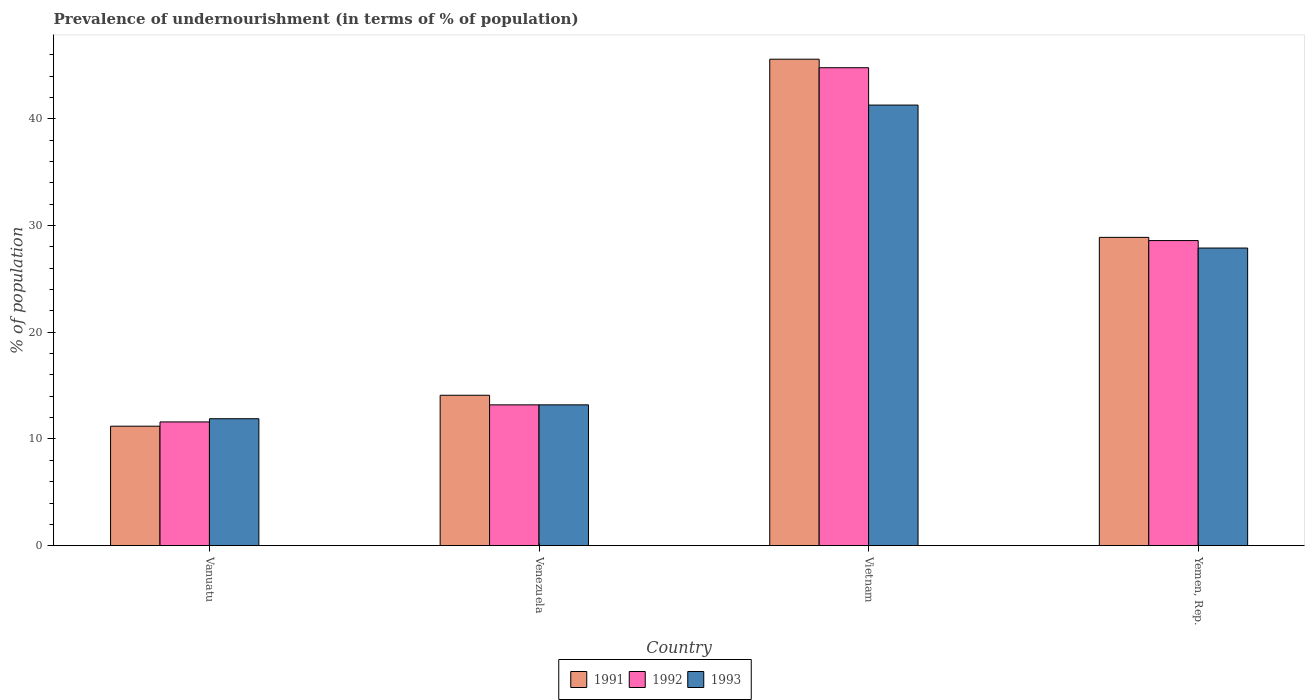How many groups of bars are there?
Offer a terse response. 4. How many bars are there on the 2nd tick from the right?
Your answer should be compact. 3. What is the label of the 2nd group of bars from the left?
Provide a short and direct response. Venezuela. In how many cases, is the number of bars for a given country not equal to the number of legend labels?
Keep it short and to the point. 0. What is the percentage of undernourished population in 1991 in Vietnam?
Your answer should be very brief. 45.6. Across all countries, what is the maximum percentage of undernourished population in 1991?
Your answer should be compact. 45.6. In which country was the percentage of undernourished population in 1992 maximum?
Offer a very short reply. Vietnam. In which country was the percentage of undernourished population in 1993 minimum?
Your answer should be very brief. Vanuatu. What is the total percentage of undernourished population in 1992 in the graph?
Make the answer very short. 98.2. What is the difference between the percentage of undernourished population in 1992 in Venezuela and that in Yemen, Rep.?
Provide a short and direct response. -15.4. What is the average percentage of undernourished population in 1993 per country?
Give a very brief answer. 23.58. What is the difference between the percentage of undernourished population of/in 1992 and percentage of undernourished population of/in 1991 in Venezuela?
Your answer should be compact. -0.9. In how many countries, is the percentage of undernourished population in 1993 greater than 14 %?
Your response must be concise. 2. What is the ratio of the percentage of undernourished population in 1991 in Vanuatu to that in Yemen, Rep.?
Your response must be concise. 0.39. Is the percentage of undernourished population in 1993 in Venezuela less than that in Yemen, Rep.?
Provide a succinct answer. Yes. What is the difference between the highest and the second highest percentage of undernourished population in 1992?
Your response must be concise. -31.6. What is the difference between the highest and the lowest percentage of undernourished population in 1992?
Provide a succinct answer. 33.2. Is the sum of the percentage of undernourished population in 1993 in Vanuatu and Yemen, Rep. greater than the maximum percentage of undernourished population in 1991 across all countries?
Your response must be concise. No. Is it the case that in every country, the sum of the percentage of undernourished population in 1991 and percentage of undernourished population in 1992 is greater than the percentage of undernourished population in 1993?
Your response must be concise. Yes. How many bars are there?
Keep it short and to the point. 12. Are all the bars in the graph horizontal?
Offer a very short reply. No. How many countries are there in the graph?
Provide a succinct answer. 4. Where does the legend appear in the graph?
Provide a short and direct response. Bottom center. What is the title of the graph?
Offer a very short reply. Prevalence of undernourishment (in terms of % of population). What is the label or title of the X-axis?
Offer a very short reply. Country. What is the label or title of the Y-axis?
Provide a short and direct response. % of population. What is the % of population of 1991 in Vanuatu?
Ensure brevity in your answer.  11.2. What is the % of population in 1992 in Vanuatu?
Your answer should be very brief. 11.6. What is the % of population of 1993 in Vanuatu?
Make the answer very short. 11.9. What is the % of population in 1991 in Venezuela?
Offer a very short reply. 14.1. What is the % of population in 1993 in Venezuela?
Provide a succinct answer. 13.2. What is the % of population in 1991 in Vietnam?
Your response must be concise. 45.6. What is the % of population of 1992 in Vietnam?
Your answer should be very brief. 44.8. What is the % of population of 1993 in Vietnam?
Give a very brief answer. 41.3. What is the % of population in 1991 in Yemen, Rep.?
Provide a short and direct response. 28.9. What is the % of population of 1992 in Yemen, Rep.?
Provide a succinct answer. 28.6. What is the % of population of 1993 in Yemen, Rep.?
Your answer should be very brief. 27.9. Across all countries, what is the maximum % of population in 1991?
Ensure brevity in your answer.  45.6. Across all countries, what is the maximum % of population of 1992?
Provide a succinct answer. 44.8. Across all countries, what is the maximum % of population of 1993?
Your response must be concise. 41.3. Across all countries, what is the minimum % of population of 1992?
Offer a very short reply. 11.6. Across all countries, what is the minimum % of population in 1993?
Your answer should be very brief. 11.9. What is the total % of population in 1991 in the graph?
Keep it short and to the point. 99.8. What is the total % of population in 1992 in the graph?
Your answer should be very brief. 98.2. What is the total % of population in 1993 in the graph?
Provide a short and direct response. 94.3. What is the difference between the % of population in 1991 in Vanuatu and that in Venezuela?
Your answer should be compact. -2.9. What is the difference between the % of population in 1991 in Vanuatu and that in Vietnam?
Provide a succinct answer. -34.4. What is the difference between the % of population of 1992 in Vanuatu and that in Vietnam?
Offer a terse response. -33.2. What is the difference between the % of population of 1993 in Vanuatu and that in Vietnam?
Provide a succinct answer. -29.4. What is the difference between the % of population of 1991 in Vanuatu and that in Yemen, Rep.?
Your answer should be compact. -17.7. What is the difference between the % of population of 1992 in Vanuatu and that in Yemen, Rep.?
Give a very brief answer. -17. What is the difference between the % of population in 1991 in Venezuela and that in Vietnam?
Make the answer very short. -31.5. What is the difference between the % of population in 1992 in Venezuela and that in Vietnam?
Offer a terse response. -31.6. What is the difference between the % of population of 1993 in Venezuela and that in Vietnam?
Keep it short and to the point. -28.1. What is the difference between the % of population in 1991 in Venezuela and that in Yemen, Rep.?
Your answer should be very brief. -14.8. What is the difference between the % of population of 1992 in Venezuela and that in Yemen, Rep.?
Your response must be concise. -15.4. What is the difference between the % of population in 1993 in Venezuela and that in Yemen, Rep.?
Your answer should be compact. -14.7. What is the difference between the % of population of 1992 in Vietnam and that in Yemen, Rep.?
Your answer should be compact. 16.2. What is the difference between the % of population in 1991 in Vanuatu and the % of population in 1992 in Venezuela?
Offer a very short reply. -2. What is the difference between the % of population in 1992 in Vanuatu and the % of population in 1993 in Venezuela?
Your response must be concise. -1.6. What is the difference between the % of population of 1991 in Vanuatu and the % of population of 1992 in Vietnam?
Offer a terse response. -33.6. What is the difference between the % of population in 1991 in Vanuatu and the % of population in 1993 in Vietnam?
Your answer should be compact. -30.1. What is the difference between the % of population in 1992 in Vanuatu and the % of population in 1993 in Vietnam?
Provide a succinct answer. -29.7. What is the difference between the % of population in 1991 in Vanuatu and the % of population in 1992 in Yemen, Rep.?
Make the answer very short. -17.4. What is the difference between the % of population of 1991 in Vanuatu and the % of population of 1993 in Yemen, Rep.?
Offer a terse response. -16.7. What is the difference between the % of population in 1992 in Vanuatu and the % of population in 1993 in Yemen, Rep.?
Keep it short and to the point. -16.3. What is the difference between the % of population of 1991 in Venezuela and the % of population of 1992 in Vietnam?
Make the answer very short. -30.7. What is the difference between the % of population of 1991 in Venezuela and the % of population of 1993 in Vietnam?
Make the answer very short. -27.2. What is the difference between the % of population of 1992 in Venezuela and the % of population of 1993 in Vietnam?
Keep it short and to the point. -28.1. What is the difference between the % of population in 1991 in Venezuela and the % of population in 1992 in Yemen, Rep.?
Keep it short and to the point. -14.5. What is the difference between the % of population in 1991 in Venezuela and the % of population in 1993 in Yemen, Rep.?
Your answer should be compact. -13.8. What is the difference between the % of population in 1992 in Venezuela and the % of population in 1993 in Yemen, Rep.?
Your answer should be very brief. -14.7. What is the difference between the % of population of 1991 in Vietnam and the % of population of 1992 in Yemen, Rep.?
Offer a terse response. 17. What is the difference between the % of population of 1991 in Vietnam and the % of population of 1993 in Yemen, Rep.?
Give a very brief answer. 17.7. What is the difference between the % of population of 1992 in Vietnam and the % of population of 1993 in Yemen, Rep.?
Your answer should be compact. 16.9. What is the average % of population in 1991 per country?
Ensure brevity in your answer.  24.95. What is the average % of population in 1992 per country?
Your answer should be compact. 24.55. What is the average % of population in 1993 per country?
Offer a terse response. 23.57. What is the difference between the % of population in 1991 and % of population in 1993 in Vanuatu?
Your answer should be very brief. -0.7. What is the difference between the % of population of 1992 and % of population of 1993 in Vanuatu?
Ensure brevity in your answer.  -0.3. What is the difference between the % of population of 1991 and % of population of 1992 in Venezuela?
Your answer should be very brief. 0.9. What is the difference between the % of population in 1991 and % of population in 1992 in Vietnam?
Make the answer very short. 0.8. What is the difference between the % of population of 1991 and % of population of 1992 in Yemen, Rep.?
Your response must be concise. 0.3. What is the difference between the % of population in 1991 and % of population in 1993 in Yemen, Rep.?
Make the answer very short. 1. What is the difference between the % of population in 1992 and % of population in 1993 in Yemen, Rep.?
Provide a succinct answer. 0.7. What is the ratio of the % of population in 1991 in Vanuatu to that in Venezuela?
Provide a succinct answer. 0.79. What is the ratio of the % of population of 1992 in Vanuatu to that in Venezuela?
Your answer should be very brief. 0.88. What is the ratio of the % of population in 1993 in Vanuatu to that in Venezuela?
Offer a terse response. 0.9. What is the ratio of the % of population of 1991 in Vanuatu to that in Vietnam?
Your response must be concise. 0.25. What is the ratio of the % of population in 1992 in Vanuatu to that in Vietnam?
Provide a short and direct response. 0.26. What is the ratio of the % of population in 1993 in Vanuatu to that in Vietnam?
Provide a succinct answer. 0.29. What is the ratio of the % of population in 1991 in Vanuatu to that in Yemen, Rep.?
Provide a short and direct response. 0.39. What is the ratio of the % of population in 1992 in Vanuatu to that in Yemen, Rep.?
Provide a succinct answer. 0.41. What is the ratio of the % of population in 1993 in Vanuatu to that in Yemen, Rep.?
Keep it short and to the point. 0.43. What is the ratio of the % of population of 1991 in Venezuela to that in Vietnam?
Provide a short and direct response. 0.31. What is the ratio of the % of population of 1992 in Venezuela to that in Vietnam?
Give a very brief answer. 0.29. What is the ratio of the % of population in 1993 in Venezuela to that in Vietnam?
Offer a terse response. 0.32. What is the ratio of the % of population of 1991 in Venezuela to that in Yemen, Rep.?
Provide a succinct answer. 0.49. What is the ratio of the % of population of 1992 in Venezuela to that in Yemen, Rep.?
Make the answer very short. 0.46. What is the ratio of the % of population in 1993 in Venezuela to that in Yemen, Rep.?
Offer a very short reply. 0.47. What is the ratio of the % of population of 1991 in Vietnam to that in Yemen, Rep.?
Provide a short and direct response. 1.58. What is the ratio of the % of population of 1992 in Vietnam to that in Yemen, Rep.?
Provide a succinct answer. 1.57. What is the ratio of the % of population in 1993 in Vietnam to that in Yemen, Rep.?
Your answer should be very brief. 1.48. What is the difference between the highest and the second highest % of population of 1991?
Provide a short and direct response. 16.7. What is the difference between the highest and the second highest % of population of 1993?
Your answer should be very brief. 13.4. What is the difference between the highest and the lowest % of population in 1991?
Your answer should be very brief. 34.4. What is the difference between the highest and the lowest % of population in 1992?
Give a very brief answer. 33.2. What is the difference between the highest and the lowest % of population in 1993?
Give a very brief answer. 29.4. 